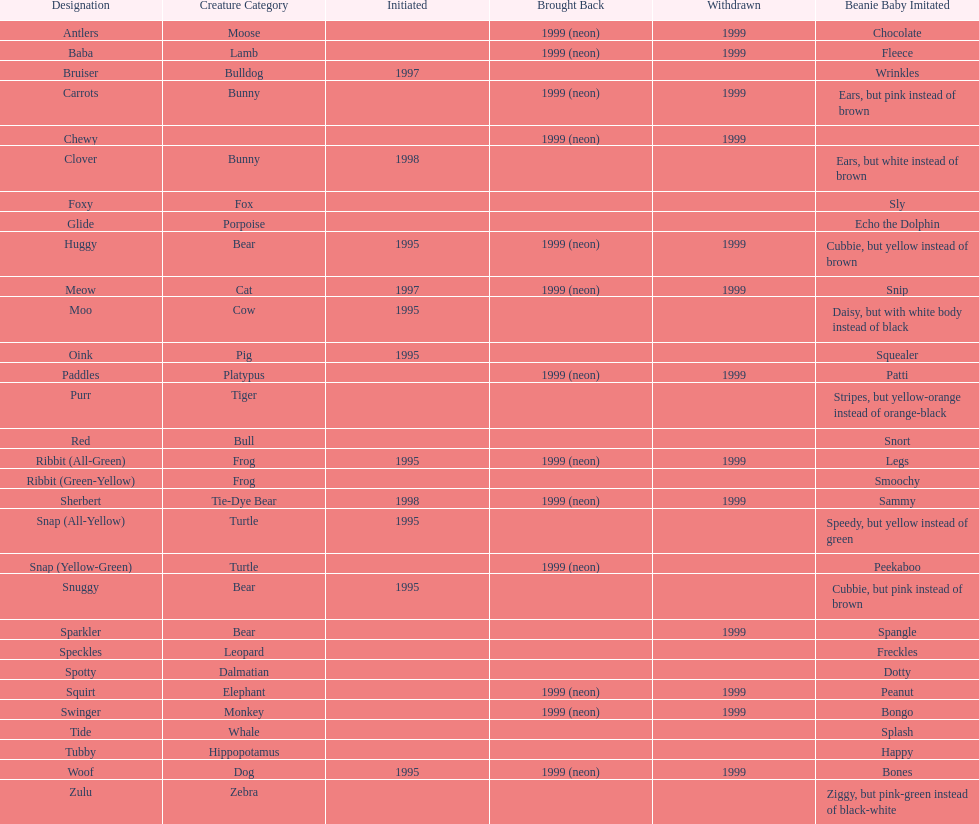What is the number of frog pillow pals? 2. 